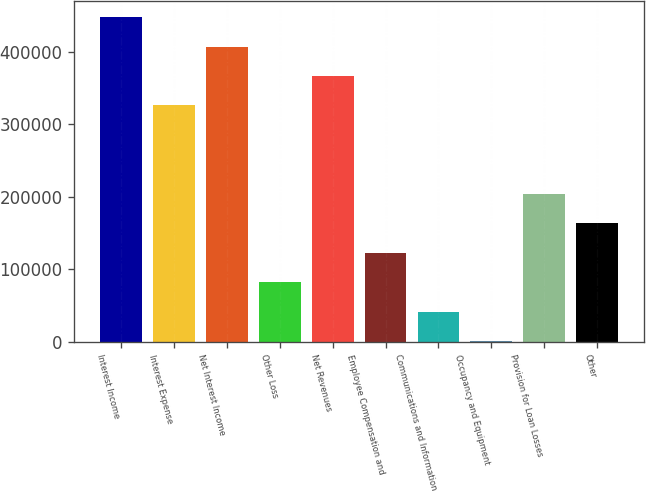Convert chart. <chart><loc_0><loc_0><loc_500><loc_500><bar_chart><fcel>Interest Income<fcel>Interest Expense<fcel>Net Interest Income<fcel>Other Loss<fcel>Net Revenues<fcel>Employee Compensation and<fcel>Communications and Information<fcel>Occupancy and Equipment<fcel>Provision for Loan Losses<fcel>Other<nl><fcel>447763<fcel>325843<fcel>407123<fcel>82001.4<fcel>366483<fcel>122642<fcel>41361.2<fcel>721<fcel>203922<fcel>163282<nl></chart> 